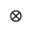<formula> <loc_0><loc_0><loc_500><loc_500>\otimes</formula> 